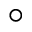<formula> <loc_0><loc_0><loc_500><loc_500>\circ</formula> 